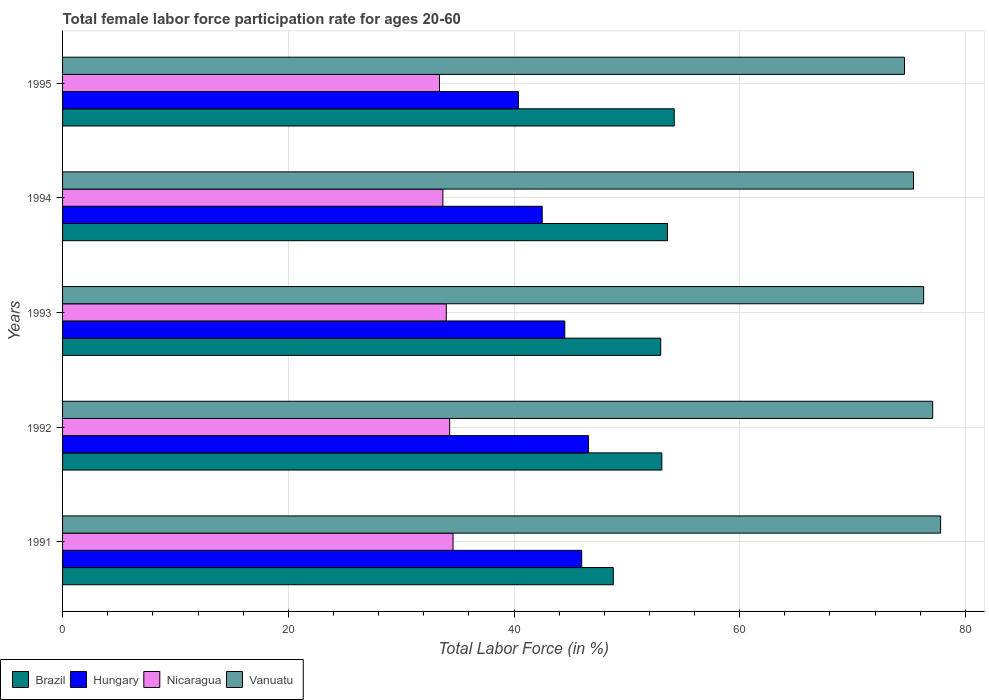Are the number of bars per tick equal to the number of legend labels?
Provide a short and direct response. Yes. How many bars are there on the 3rd tick from the top?
Give a very brief answer. 4. How many bars are there on the 1st tick from the bottom?
Offer a very short reply. 4. What is the label of the 2nd group of bars from the top?
Provide a succinct answer. 1994. What is the female labor force participation rate in Hungary in 1993?
Provide a succinct answer. 44.5. Across all years, what is the maximum female labor force participation rate in Brazil?
Make the answer very short. 54.2. Across all years, what is the minimum female labor force participation rate in Brazil?
Keep it short and to the point. 48.8. What is the total female labor force participation rate in Nicaragua in the graph?
Provide a succinct answer. 170. What is the difference between the female labor force participation rate in Nicaragua in 1991 and that in 1995?
Provide a short and direct response. 1.2. What is the difference between the female labor force participation rate in Hungary in 1993 and the female labor force participation rate in Brazil in 1991?
Offer a very short reply. -4.3. What is the average female labor force participation rate in Brazil per year?
Offer a very short reply. 52.54. In the year 1995, what is the difference between the female labor force participation rate in Brazil and female labor force participation rate in Vanuatu?
Your response must be concise. -20.4. What is the ratio of the female labor force participation rate in Hungary in 1992 to that in 1995?
Give a very brief answer. 1.15. Is the difference between the female labor force participation rate in Brazil in 1994 and 1995 greater than the difference between the female labor force participation rate in Vanuatu in 1994 and 1995?
Provide a short and direct response. No. What is the difference between the highest and the second highest female labor force participation rate in Hungary?
Offer a very short reply. 0.6. What is the difference between the highest and the lowest female labor force participation rate in Hungary?
Ensure brevity in your answer.  6.2. In how many years, is the female labor force participation rate in Hungary greater than the average female labor force participation rate in Hungary taken over all years?
Provide a succinct answer. 3. What does the 2nd bar from the top in 1994 represents?
Give a very brief answer. Nicaragua. What does the 3rd bar from the bottom in 1993 represents?
Make the answer very short. Nicaragua. How many bars are there?
Offer a terse response. 20. What is the difference between two consecutive major ticks on the X-axis?
Your answer should be very brief. 20. Where does the legend appear in the graph?
Your response must be concise. Bottom left. How many legend labels are there?
Offer a terse response. 4. How are the legend labels stacked?
Provide a succinct answer. Horizontal. What is the title of the graph?
Offer a very short reply. Total female labor force participation rate for ages 20-60. What is the label or title of the X-axis?
Ensure brevity in your answer.  Total Labor Force (in %). What is the label or title of the Y-axis?
Provide a succinct answer. Years. What is the Total Labor Force (in %) of Brazil in 1991?
Keep it short and to the point. 48.8. What is the Total Labor Force (in %) in Nicaragua in 1991?
Your answer should be compact. 34.6. What is the Total Labor Force (in %) of Vanuatu in 1991?
Ensure brevity in your answer.  77.8. What is the Total Labor Force (in %) of Brazil in 1992?
Ensure brevity in your answer.  53.1. What is the Total Labor Force (in %) in Hungary in 1992?
Provide a short and direct response. 46.6. What is the Total Labor Force (in %) of Nicaragua in 1992?
Your response must be concise. 34.3. What is the Total Labor Force (in %) in Vanuatu in 1992?
Provide a short and direct response. 77.1. What is the Total Labor Force (in %) in Brazil in 1993?
Your response must be concise. 53. What is the Total Labor Force (in %) of Hungary in 1993?
Give a very brief answer. 44.5. What is the Total Labor Force (in %) in Nicaragua in 1993?
Make the answer very short. 34. What is the Total Labor Force (in %) in Vanuatu in 1993?
Make the answer very short. 76.3. What is the Total Labor Force (in %) of Brazil in 1994?
Offer a terse response. 53.6. What is the Total Labor Force (in %) of Hungary in 1994?
Make the answer very short. 42.5. What is the Total Labor Force (in %) in Nicaragua in 1994?
Your response must be concise. 33.7. What is the Total Labor Force (in %) of Vanuatu in 1994?
Offer a terse response. 75.4. What is the Total Labor Force (in %) of Brazil in 1995?
Offer a terse response. 54.2. What is the Total Labor Force (in %) of Hungary in 1995?
Your answer should be compact. 40.4. What is the Total Labor Force (in %) of Nicaragua in 1995?
Your answer should be compact. 33.4. What is the Total Labor Force (in %) in Vanuatu in 1995?
Your response must be concise. 74.6. Across all years, what is the maximum Total Labor Force (in %) in Brazil?
Your answer should be compact. 54.2. Across all years, what is the maximum Total Labor Force (in %) in Hungary?
Ensure brevity in your answer.  46.6. Across all years, what is the maximum Total Labor Force (in %) in Nicaragua?
Your response must be concise. 34.6. Across all years, what is the maximum Total Labor Force (in %) in Vanuatu?
Give a very brief answer. 77.8. Across all years, what is the minimum Total Labor Force (in %) of Brazil?
Make the answer very short. 48.8. Across all years, what is the minimum Total Labor Force (in %) of Hungary?
Offer a terse response. 40.4. Across all years, what is the minimum Total Labor Force (in %) in Nicaragua?
Give a very brief answer. 33.4. Across all years, what is the minimum Total Labor Force (in %) in Vanuatu?
Your answer should be very brief. 74.6. What is the total Total Labor Force (in %) in Brazil in the graph?
Your response must be concise. 262.7. What is the total Total Labor Force (in %) of Hungary in the graph?
Your response must be concise. 220. What is the total Total Labor Force (in %) in Nicaragua in the graph?
Offer a very short reply. 170. What is the total Total Labor Force (in %) of Vanuatu in the graph?
Ensure brevity in your answer.  381.2. What is the difference between the Total Labor Force (in %) of Brazil in 1991 and that in 1992?
Give a very brief answer. -4.3. What is the difference between the Total Labor Force (in %) of Hungary in 1991 and that in 1992?
Give a very brief answer. -0.6. What is the difference between the Total Labor Force (in %) of Nicaragua in 1991 and that in 1992?
Make the answer very short. 0.3. What is the difference between the Total Labor Force (in %) of Brazil in 1991 and that in 1993?
Offer a terse response. -4.2. What is the difference between the Total Labor Force (in %) in Hungary in 1991 and that in 1993?
Give a very brief answer. 1.5. What is the difference between the Total Labor Force (in %) in Nicaragua in 1991 and that in 1994?
Provide a succinct answer. 0.9. What is the difference between the Total Labor Force (in %) of Brazil in 1991 and that in 1995?
Your response must be concise. -5.4. What is the difference between the Total Labor Force (in %) in Hungary in 1991 and that in 1995?
Provide a short and direct response. 5.6. What is the difference between the Total Labor Force (in %) in Hungary in 1992 and that in 1993?
Provide a succinct answer. 2.1. What is the difference between the Total Labor Force (in %) of Nicaragua in 1992 and that in 1993?
Make the answer very short. 0.3. What is the difference between the Total Labor Force (in %) in Nicaragua in 1992 and that in 1994?
Give a very brief answer. 0.6. What is the difference between the Total Labor Force (in %) of Vanuatu in 1992 and that in 1994?
Ensure brevity in your answer.  1.7. What is the difference between the Total Labor Force (in %) in Brazil in 1992 and that in 1995?
Keep it short and to the point. -1.1. What is the difference between the Total Labor Force (in %) in Hungary in 1992 and that in 1995?
Your answer should be very brief. 6.2. What is the difference between the Total Labor Force (in %) in Nicaragua in 1992 and that in 1995?
Offer a terse response. 0.9. What is the difference between the Total Labor Force (in %) of Hungary in 1993 and that in 1994?
Provide a short and direct response. 2. What is the difference between the Total Labor Force (in %) in Vanuatu in 1993 and that in 1994?
Offer a terse response. 0.9. What is the difference between the Total Labor Force (in %) of Hungary in 1993 and that in 1995?
Your answer should be compact. 4.1. What is the difference between the Total Labor Force (in %) in Nicaragua in 1993 and that in 1995?
Make the answer very short. 0.6. What is the difference between the Total Labor Force (in %) in Brazil in 1994 and that in 1995?
Provide a succinct answer. -0.6. What is the difference between the Total Labor Force (in %) in Hungary in 1994 and that in 1995?
Make the answer very short. 2.1. What is the difference between the Total Labor Force (in %) in Nicaragua in 1994 and that in 1995?
Offer a terse response. 0.3. What is the difference between the Total Labor Force (in %) in Vanuatu in 1994 and that in 1995?
Make the answer very short. 0.8. What is the difference between the Total Labor Force (in %) in Brazil in 1991 and the Total Labor Force (in %) in Hungary in 1992?
Your answer should be compact. 2.2. What is the difference between the Total Labor Force (in %) of Brazil in 1991 and the Total Labor Force (in %) of Vanuatu in 1992?
Offer a very short reply. -28.3. What is the difference between the Total Labor Force (in %) in Hungary in 1991 and the Total Labor Force (in %) in Nicaragua in 1992?
Offer a terse response. 11.7. What is the difference between the Total Labor Force (in %) in Hungary in 1991 and the Total Labor Force (in %) in Vanuatu in 1992?
Your response must be concise. -31.1. What is the difference between the Total Labor Force (in %) in Nicaragua in 1991 and the Total Labor Force (in %) in Vanuatu in 1992?
Your answer should be very brief. -42.5. What is the difference between the Total Labor Force (in %) in Brazil in 1991 and the Total Labor Force (in %) in Hungary in 1993?
Make the answer very short. 4.3. What is the difference between the Total Labor Force (in %) in Brazil in 1991 and the Total Labor Force (in %) in Nicaragua in 1993?
Your answer should be compact. 14.8. What is the difference between the Total Labor Force (in %) of Brazil in 1991 and the Total Labor Force (in %) of Vanuatu in 1993?
Offer a very short reply. -27.5. What is the difference between the Total Labor Force (in %) in Hungary in 1991 and the Total Labor Force (in %) in Nicaragua in 1993?
Offer a very short reply. 12. What is the difference between the Total Labor Force (in %) in Hungary in 1991 and the Total Labor Force (in %) in Vanuatu in 1993?
Provide a short and direct response. -30.3. What is the difference between the Total Labor Force (in %) in Nicaragua in 1991 and the Total Labor Force (in %) in Vanuatu in 1993?
Offer a terse response. -41.7. What is the difference between the Total Labor Force (in %) of Brazil in 1991 and the Total Labor Force (in %) of Nicaragua in 1994?
Give a very brief answer. 15.1. What is the difference between the Total Labor Force (in %) of Brazil in 1991 and the Total Labor Force (in %) of Vanuatu in 1994?
Keep it short and to the point. -26.6. What is the difference between the Total Labor Force (in %) in Hungary in 1991 and the Total Labor Force (in %) in Nicaragua in 1994?
Offer a terse response. 12.3. What is the difference between the Total Labor Force (in %) in Hungary in 1991 and the Total Labor Force (in %) in Vanuatu in 1994?
Provide a succinct answer. -29.4. What is the difference between the Total Labor Force (in %) of Nicaragua in 1991 and the Total Labor Force (in %) of Vanuatu in 1994?
Offer a terse response. -40.8. What is the difference between the Total Labor Force (in %) in Brazil in 1991 and the Total Labor Force (in %) in Vanuatu in 1995?
Provide a short and direct response. -25.8. What is the difference between the Total Labor Force (in %) of Hungary in 1991 and the Total Labor Force (in %) of Vanuatu in 1995?
Your answer should be very brief. -28.6. What is the difference between the Total Labor Force (in %) in Brazil in 1992 and the Total Labor Force (in %) in Hungary in 1993?
Your answer should be compact. 8.6. What is the difference between the Total Labor Force (in %) of Brazil in 1992 and the Total Labor Force (in %) of Vanuatu in 1993?
Offer a terse response. -23.2. What is the difference between the Total Labor Force (in %) in Hungary in 1992 and the Total Labor Force (in %) in Vanuatu in 1993?
Give a very brief answer. -29.7. What is the difference between the Total Labor Force (in %) of Nicaragua in 1992 and the Total Labor Force (in %) of Vanuatu in 1993?
Your response must be concise. -42. What is the difference between the Total Labor Force (in %) of Brazil in 1992 and the Total Labor Force (in %) of Hungary in 1994?
Make the answer very short. 10.6. What is the difference between the Total Labor Force (in %) in Brazil in 1992 and the Total Labor Force (in %) in Nicaragua in 1994?
Your answer should be compact. 19.4. What is the difference between the Total Labor Force (in %) in Brazil in 1992 and the Total Labor Force (in %) in Vanuatu in 1994?
Give a very brief answer. -22.3. What is the difference between the Total Labor Force (in %) in Hungary in 1992 and the Total Labor Force (in %) in Vanuatu in 1994?
Ensure brevity in your answer.  -28.8. What is the difference between the Total Labor Force (in %) in Nicaragua in 1992 and the Total Labor Force (in %) in Vanuatu in 1994?
Ensure brevity in your answer.  -41.1. What is the difference between the Total Labor Force (in %) in Brazil in 1992 and the Total Labor Force (in %) in Nicaragua in 1995?
Keep it short and to the point. 19.7. What is the difference between the Total Labor Force (in %) in Brazil in 1992 and the Total Labor Force (in %) in Vanuatu in 1995?
Make the answer very short. -21.5. What is the difference between the Total Labor Force (in %) of Hungary in 1992 and the Total Labor Force (in %) of Vanuatu in 1995?
Keep it short and to the point. -28. What is the difference between the Total Labor Force (in %) in Nicaragua in 1992 and the Total Labor Force (in %) in Vanuatu in 1995?
Make the answer very short. -40.3. What is the difference between the Total Labor Force (in %) of Brazil in 1993 and the Total Labor Force (in %) of Hungary in 1994?
Your answer should be compact. 10.5. What is the difference between the Total Labor Force (in %) in Brazil in 1993 and the Total Labor Force (in %) in Nicaragua in 1994?
Ensure brevity in your answer.  19.3. What is the difference between the Total Labor Force (in %) in Brazil in 1993 and the Total Labor Force (in %) in Vanuatu in 1994?
Provide a short and direct response. -22.4. What is the difference between the Total Labor Force (in %) of Hungary in 1993 and the Total Labor Force (in %) of Vanuatu in 1994?
Offer a terse response. -30.9. What is the difference between the Total Labor Force (in %) of Nicaragua in 1993 and the Total Labor Force (in %) of Vanuatu in 1994?
Offer a terse response. -41.4. What is the difference between the Total Labor Force (in %) in Brazil in 1993 and the Total Labor Force (in %) in Hungary in 1995?
Give a very brief answer. 12.6. What is the difference between the Total Labor Force (in %) in Brazil in 1993 and the Total Labor Force (in %) in Nicaragua in 1995?
Your answer should be very brief. 19.6. What is the difference between the Total Labor Force (in %) of Brazil in 1993 and the Total Labor Force (in %) of Vanuatu in 1995?
Give a very brief answer. -21.6. What is the difference between the Total Labor Force (in %) of Hungary in 1993 and the Total Labor Force (in %) of Nicaragua in 1995?
Offer a terse response. 11.1. What is the difference between the Total Labor Force (in %) in Hungary in 1993 and the Total Labor Force (in %) in Vanuatu in 1995?
Your answer should be compact. -30.1. What is the difference between the Total Labor Force (in %) in Nicaragua in 1993 and the Total Labor Force (in %) in Vanuatu in 1995?
Your answer should be very brief. -40.6. What is the difference between the Total Labor Force (in %) of Brazil in 1994 and the Total Labor Force (in %) of Hungary in 1995?
Your answer should be very brief. 13.2. What is the difference between the Total Labor Force (in %) of Brazil in 1994 and the Total Labor Force (in %) of Nicaragua in 1995?
Provide a short and direct response. 20.2. What is the difference between the Total Labor Force (in %) of Brazil in 1994 and the Total Labor Force (in %) of Vanuatu in 1995?
Provide a succinct answer. -21. What is the difference between the Total Labor Force (in %) in Hungary in 1994 and the Total Labor Force (in %) in Vanuatu in 1995?
Provide a short and direct response. -32.1. What is the difference between the Total Labor Force (in %) in Nicaragua in 1994 and the Total Labor Force (in %) in Vanuatu in 1995?
Ensure brevity in your answer.  -40.9. What is the average Total Labor Force (in %) of Brazil per year?
Your answer should be very brief. 52.54. What is the average Total Labor Force (in %) of Vanuatu per year?
Your response must be concise. 76.24. In the year 1991, what is the difference between the Total Labor Force (in %) of Brazil and Total Labor Force (in %) of Vanuatu?
Keep it short and to the point. -29. In the year 1991, what is the difference between the Total Labor Force (in %) of Hungary and Total Labor Force (in %) of Nicaragua?
Offer a terse response. 11.4. In the year 1991, what is the difference between the Total Labor Force (in %) of Hungary and Total Labor Force (in %) of Vanuatu?
Ensure brevity in your answer.  -31.8. In the year 1991, what is the difference between the Total Labor Force (in %) of Nicaragua and Total Labor Force (in %) of Vanuatu?
Ensure brevity in your answer.  -43.2. In the year 1992, what is the difference between the Total Labor Force (in %) in Brazil and Total Labor Force (in %) in Hungary?
Offer a terse response. 6.5. In the year 1992, what is the difference between the Total Labor Force (in %) in Brazil and Total Labor Force (in %) in Nicaragua?
Provide a succinct answer. 18.8. In the year 1992, what is the difference between the Total Labor Force (in %) in Hungary and Total Labor Force (in %) in Vanuatu?
Make the answer very short. -30.5. In the year 1992, what is the difference between the Total Labor Force (in %) of Nicaragua and Total Labor Force (in %) of Vanuatu?
Your answer should be very brief. -42.8. In the year 1993, what is the difference between the Total Labor Force (in %) of Brazil and Total Labor Force (in %) of Hungary?
Your answer should be compact. 8.5. In the year 1993, what is the difference between the Total Labor Force (in %) of Brazil and Total Labor Force (in %) of Nicaragua?
Your answer should be compact. 19. In the year 1993, what is the difference between the Total Labor Force (in %) of Brazil and Total Labor Force (in %) of Vanuatu?
Offer a terse response. -23.3. In the year 1993, what is the difference between the Total Labor Force (in %) of Hungary and Total Labor Force (in %) of Vanuatu?
Your answer should be compact. -31.8. In the year 1993, what is the difference between the Total Labor Force (in %) of Nicaragua and Total Labor Force (in %) of Vanuatu?
Your response must be concise. -42.3. In the year 1994, what is the difference between the Total Labor Force (in %) of Brazil and Total Labor Force (in %) of Hungary?
Your answer should be compact. 11.1. In the year 1994, what is the difference between the Total Labor Force (in %) in Brazil and Total Labor Force (in %) in Vanuatu?
Ensure brevity in your answer.  -21.8. In the year 1994, what is the difference between the Total Labor Force (in %) in Hungary and Total Labor Force (in %) in Vanuatu?
Offer a very short reply. -32.9. In the year 1994, what is the difference between the Total Labor Force (in %) of Nicaragua and Total Labor Force (in %) of Vanuatu?
Keep it short and to the point. -41.7. In the year 1995, what is the difference between the Total Labor Force (in %) of Brazil and Total Labor Force (in %) of Nicaragua?
Keep it short and to the point. 20.8. In the year 1995, what is the difference between the Total Labor Force (in %) in Brazil and Total Labor Force (in %) in Vanuatu?
Your answer should be compact. -20.4. In the year 1995, what is the difference between the Total Labor Force (in %) of Hungary and Total Labor Force (in %) of Vanuatu?
Ensure brevity in your answer.  -34.2. In the year 1995, what is the difference between the Total Labor Force (in %) of Nicaragua and Total Labor Force (in %) of Vanuatu?
Give a very brief answer. -41.2. What is the ratio of the Total Labor Force (in %) in Brazil in 1991 to that in 1992?
Give a very brief answer. 0.92. What is the ratio of the Total Labor Force (in %) in Hungary in 1991 to that in 1992?
Ensure brevity in your answer.  0.99. What is the ratio of the Total Labor Force (in %) of Nicaragua in 1991 to that in 1992?
Keep it short and to the point. 1.01. What is the ratio of the Total Labor Force (in %) in Vanuatu in 1991 to that in 1992?
Provide a short and direct response. 1.01. What is the ratio of the Total Labor Force (in %) of Brazil in 1991 to that in 1993?
Make the answer very short. 0.92. What is the ratio of the Total Labor Force (in %) in Hungary in 1991 to that in 1993?
Keep it short and to the point. 1.03. What is the ratio of the Total Labor Force (in %) in Nicaragua in 1991 to that in 1993?
Offer a very short reply. 1.02. What is the ratio of the Total Labor Force (in %) of Vanuatu in 1991 to that in 1993?
Ensure brevity in your answer.  1.02. What is the ratio of the Total Labor Force (in %) in Brazil in 1991 to that in 1994?
Offer a terse response. 0.91. What is the ratio of the Total Labor Force (in %) in Hungary in 1991 to that in 1994?
Ensure brevity in your answer.  1.08. What is the ratio of the Total Labor Force (in %) in Nicaragua in 1991 to that in 1994?
Make the answer very short. 1.03. What is the ratio of the Total Labor Force (in %) in Vanuatu in 1991 to that in 1994?
Offer a very short reply. 1.03. What is the ratio of the Total Labor Force (in %) of Brazil in 1991 to that in 1995?
Your answer should be compact. 0.9. What is the ratio of the Total Labor Force (in %) of Hungary in 1991 to that in 1995?
Keep it short and to the point. 1.14. What is the ratio of the Total Labor Force (in %) in Nicaragua in 1991 to that in 1995?
Your response must be concise. 1.04. What is the ratio of the Total Labor Force (in %) in Vanuatu in 1991 to that in 1995?
Your answer should be compact. 1.04. What is the ratio of the Total Labor Force (in %) of Brazil in 1992 to that in 1993?
Ensure brevity in your answer.  1. What is the ratio of the Total Labor Force (in %) of Hungary in 1992 to that in 1993?
Keep it short and to the point. 1.05. What is the ratio of the Total Labor Force (in %) of Nicaragua in 1992 to that in 1993?
Your answer should be compact. 1.01. What is the ratio of the Total Labor Force (in %) in Vanuatu in 1992 to that in 1993?
Your response must be concise. 1.01. What is the ratio of the Total Labor Force (in %) of Brazil in 1992 to that in 1994?
Provide a succinct answer. 0.99. What is the ratio of the Total Labor Force (in %) in Hungary in 1992 to that in 1994?
Make the answer very short. 1.1. What is the ratio of the Total Labor Force (in %) in Nicaragua in 1992 to that in 1994?
Make the answer very short. 1.02. What is the ratio of the Total Labor Force (in %) of Vanuatu in 1992 to that in 1994?
Provide a succinct answer. 1.02. What is the ratio of the Total Labor Force (in %) of Brazil in 1992 to that in 1995?
Your response must be concise. 0.98. What is the ratio of the Total Labor Force (in %) of Hungary in 1992 to that in 1995?
Offer a very short reply. 1.15. What is the ratio of the Total Labor Force (in %) in Nicaragua in 1992 to that in 1995?
Keep it short and to the point. 1.03. What is the ratio of the Total Labor Force (in %) in Vanuatu in 1992 to that in 1995?
Keep it short and to the point. 1.03. What is the ratio of the Total Labor Force (in %) in Brazil in 1993 to that in 1994?
Offer a terse response. 0.99. What is the ratio of the Total Labor Force (in %) in Hungary in 1993 to that in 1994?
Your answer should be very brief. 1.05. What is the ratio of the Total Labor Force (in %) of Nicaragua in 1993 to that in 1994?
Give a very brief answer. 1.01. What is the ratio of the Total Labor Force (in %) of Vanuatu in 1993 to that in 1994?
Make the answer very short. 1.01. What is the ratio of the Total Labor Force (in %) of Brazil in 1993 to that in 1995?
Provide a short and direct response. 0.98. What is the ratio of the Total Labor Force (in %) of Hungary in 1993 to that in 1995?
Your response must be concise. 1.1. What is the ratio of the Total Labor Force (in %) of Vanuatu in 1993 to that in 1995?
Your response must be concise. 1.02. What is the ratio of the Total Labor Force (in %) of Brazil in 1994 to that in 1995?
Provide a succinct answer. 0.99. What is the ratio of the Total Labor Force (in %) in Hungary in 1994 to that in 1995?
Offer a very short reply. 1.05. What is the ratio of the Total Labor Force (in %) in Nicaragua in 1994 to that in 1995?
Your response must be concise. 1.01. What is the ratio of the Total Labor Force (in %) of Vanuatu in 1994 to that in 1995?
Keep it short and to the point. 1.01. What is the difference between the highest and the second highest Total Labor Force (in %) of Hungary?
Provide a short and direct response. 0.6. What is the difference between the highest and the second highest Total Labor Force (in %) in Nicaragua?
Your answer should be very brief. 0.3. What is the difference between the highest and the lowest Total Labor Force (in %) in Nicaragua?
Ensure brevity in your answer.  1.2. 